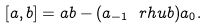Convert formula to latex. <formula><loc_0><loc_0><loc_500><loc_500>[ a , b ] = a b - ( a _ { - 1 } \ r h u b ) a _ { 0 } .</formula> 